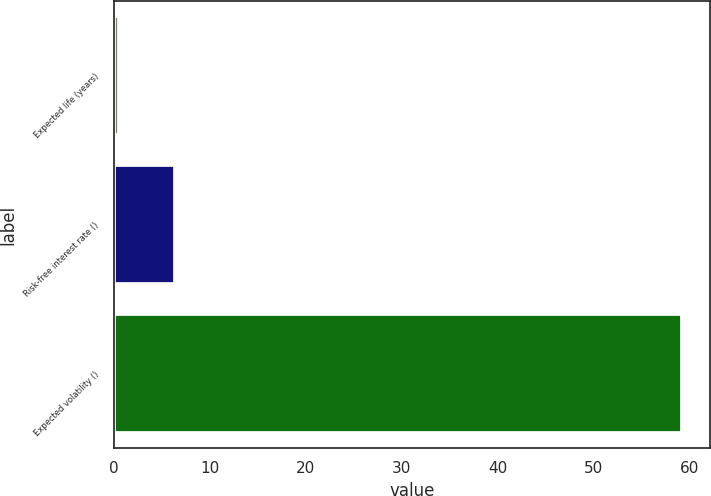<chart> <loc_0><loc_0><loc_500><loc_500><bar_chart><fcel>Expected life (years)<fcel>Risk-free interest rate ()<fcel>Expected volatility ()<nl><fcel>0.5<fcel>6.37<fcel>59.2<nl></chart> 